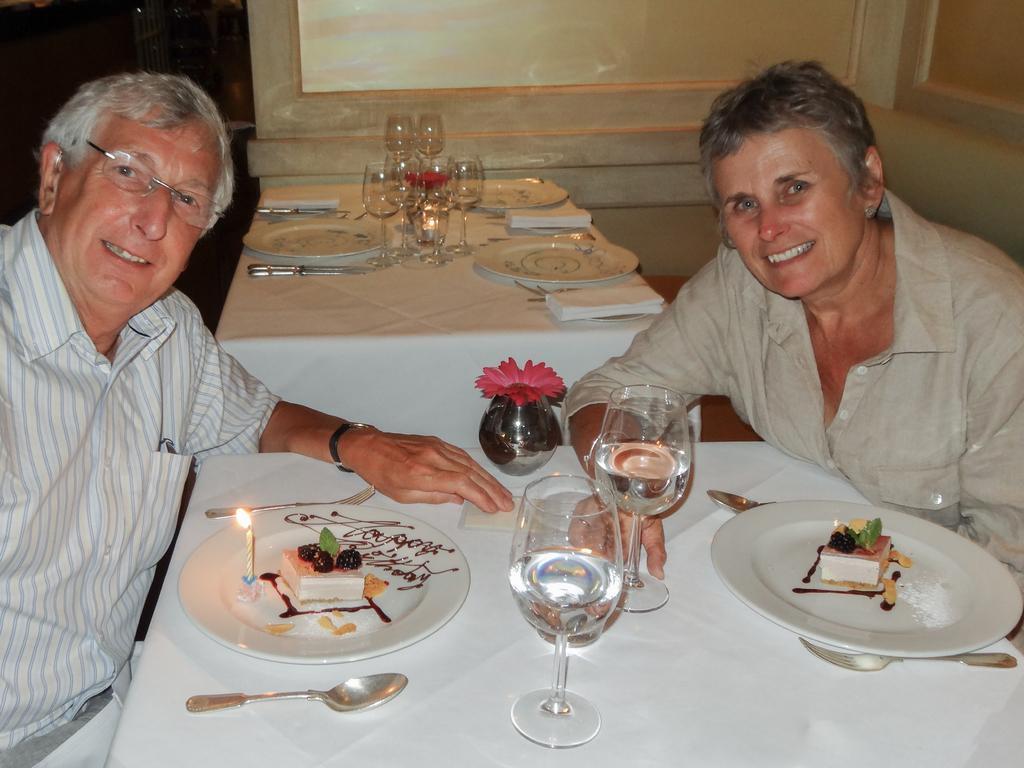Describe this image in one or two sentences. In this image I can see two persons sitting. In front I can see few glasses, spoons, plates and I can also see the food in the plates. Background the wall is in cream color. 